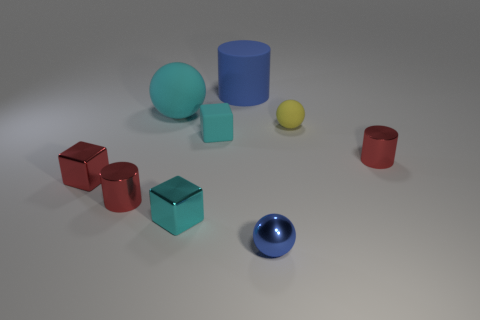Is the material of the tiny red thing that is right of the blue ball the same as the large sphere?
Give a very brief answer. No. Are there the same number of small cylinders behind the blue rubber cylinder and red shiny blocks to the left of the cyan metallic block?
Provide a short and direct response. No. What size is the object that is behind the ball on the left side of the tiny blue ball?
Keep it short and to the point. Large. What material is the thing that is in front of the yellow object and right of the blue shiny thing?
Make the answer very short. Metal. How many other things are the same size as the cyan metal block?
Keep it short and to the point. 6. The small shiny sphere is what color?
Keep it short and to the point. Blue. There is a shiny block to the right of the tiny red cube; is its color the same as the sphere left of the big blue matte object?
Give a very brief answer. Yes. The blue matte cylinder has what size?
Your answer should be very brief. Large. What is the size of the metal thing on the right side of the small yellow matte sphere?
Your response must be concise. Small. What shape is the thing that is both behind the tiny cyan rubber block and on the right side of the big matte cylinder?
Give a very brief answer. Sphere. 